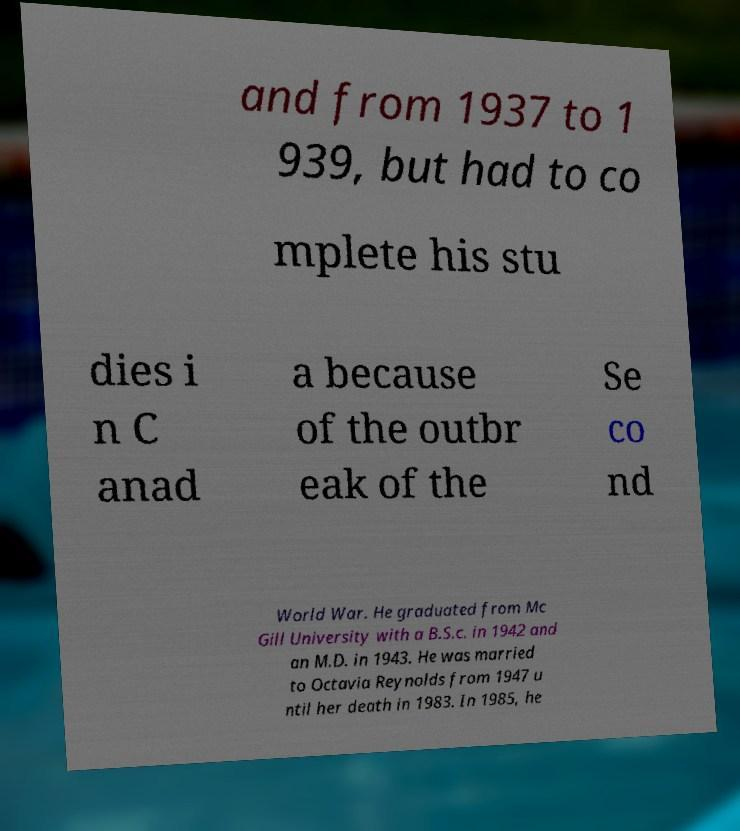What messages or text are displayed in this image? I need them in a readable, typed format. and from 1937 to 1 939, but had to co mplete his stu dies i n C anad a because of the outbr eak of the Se co nd World War. He graduated from Mc Gill University with a B.S.c. in 1942 and an M.D. in 1943. He was married to Octavia Reynolds from 1947 u ntil her death in 1983. In 1985, he 